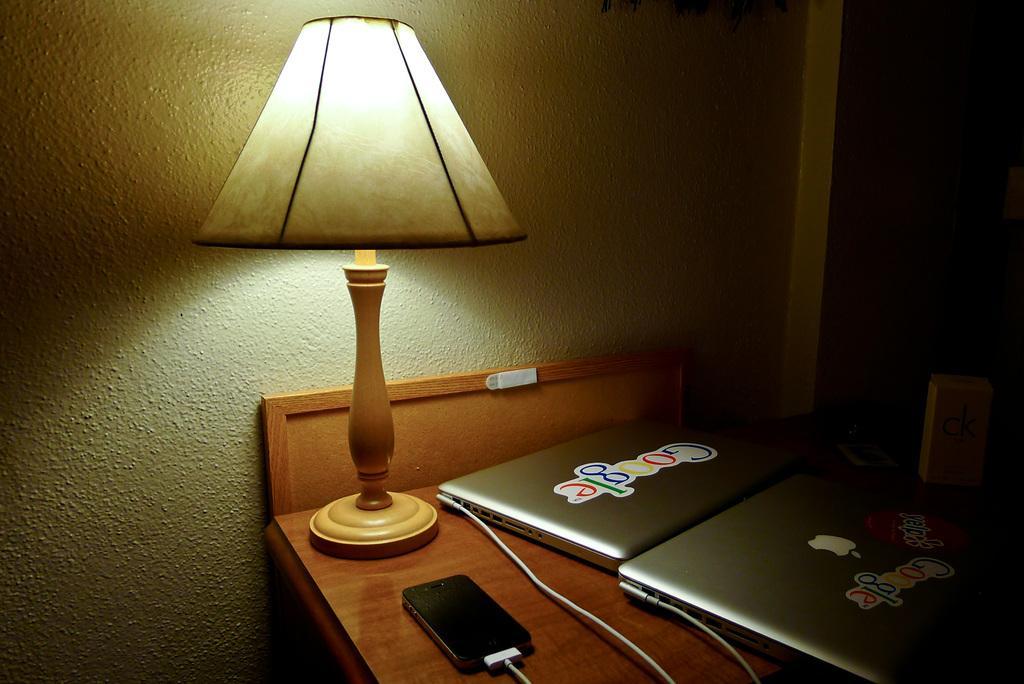How would you summarize this image in a sentence or two? In this picture I can see table lamp. I can see electronic devices on the table. I can see the wall in the background. 